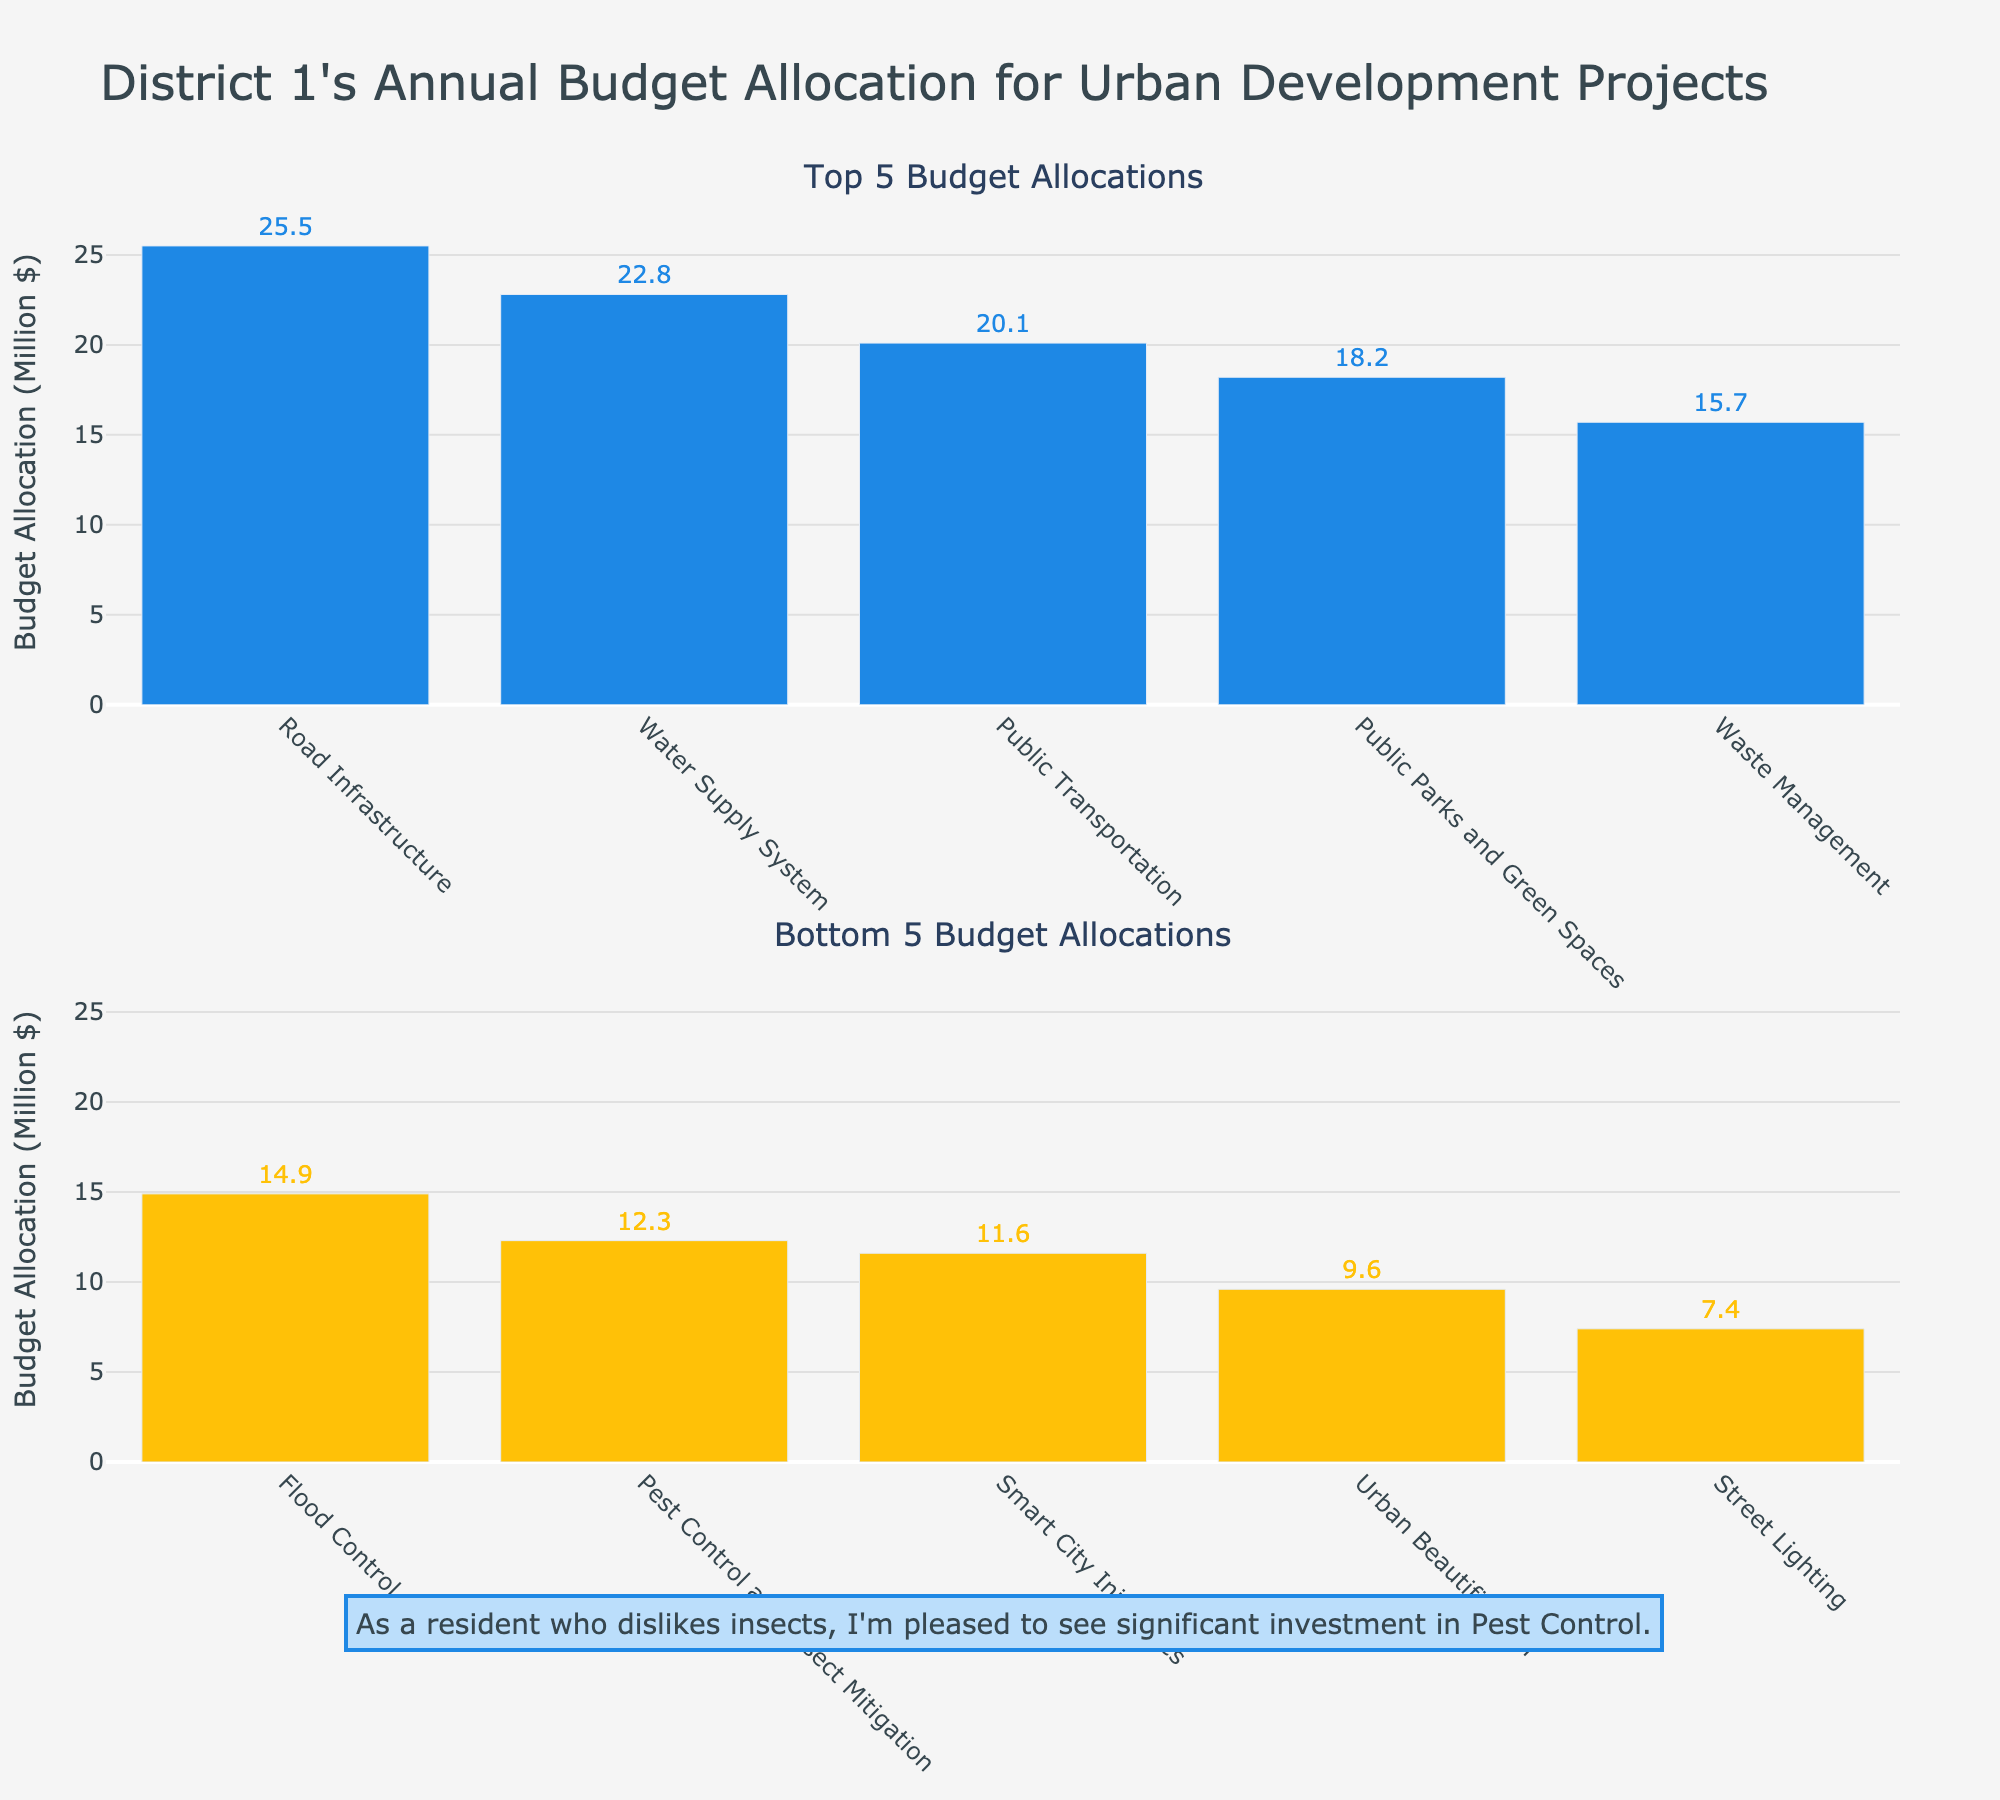What is the title of the figure? The title of the figure is displayed at the top and reads "District 1's Annual Budget Allocation for Urban Development Projects."
Answer: District 1's Annual Budget Allocation for Urban Development Projects What is the allocated budget for Public Transportation? In the top subplot, the bar representing Public Transportation is labeled with its budget, which is $20.1 million.
Answer: $20.1 million How much more is allocated to Road Infrastructure compared to Pest Control and Insect Mitigation? The budget for Road Infrastructure is $25.5 million and for Pest Control and Insect Mitigation, it's $12.3 million. The difference is $25.5 million - $12.3 million = $13.2 million.
Answer: $13.2 million How many projects are represented in each subplot? Both subplots are titled "Top 5 Budget Allocations" and "Bottom 5 Budget Allocations," indicating that each represents 5 projects.
Answer: 5 projects per subplot Which project has the lowest budget allocation and how much is it? In the bottom subplot, the last project listed (Street Lighting) has the lowest budget allocation of $7.4 million.
Answer: Street Lighting with $7.4 million What is the total budget allocation for the top 5 projects? The top 5 projects are Road Infrastructure ($25.5M), Water Supply System ($22.8M), Public Transportation ($20.1M), Public Parks and Green Spaces ($18.2M), and Waste Management ($15.7M). Summing these values: $25.5M + $22.8M + $20.1M + $18.2M + $15.7M = $102.3M.
Answer: $102.3 million Which project appears in both subplots, if any? The subplots are mutually exclusive, dividing the data into top 5 and bottom 5 budget allocations without overlap. Therefore, no project appears in both subplots.
Answer: None Is more budget allocated to Urban Beautification or Smart City Initiatives? And by how much? Urban Beautification ($9.6M) is in the bottom 5, while Smart City Initiatives ($11.6M) is also in the bottom 5. The difference is $11.6M - $9.6M = $2M in favor of Smart City Initiatives.
Answer: Smart City Initiatives by $2 million Which project has the third highest budget allocation? In the top 5 subplot, the third bar from the left represents Public Transportation with a budget of $20.1 million.
Answer: Public Transportation What is the sum of the budget allocations for Flood Control and Street Lighting? Flood Control ($14.9M) is in the bottom 5 and Street Lighting ($7.4M) is also in the bottom 5. Summing these: $14.9M + $7.4M = $22.3M.
Answer: $22.3 million 